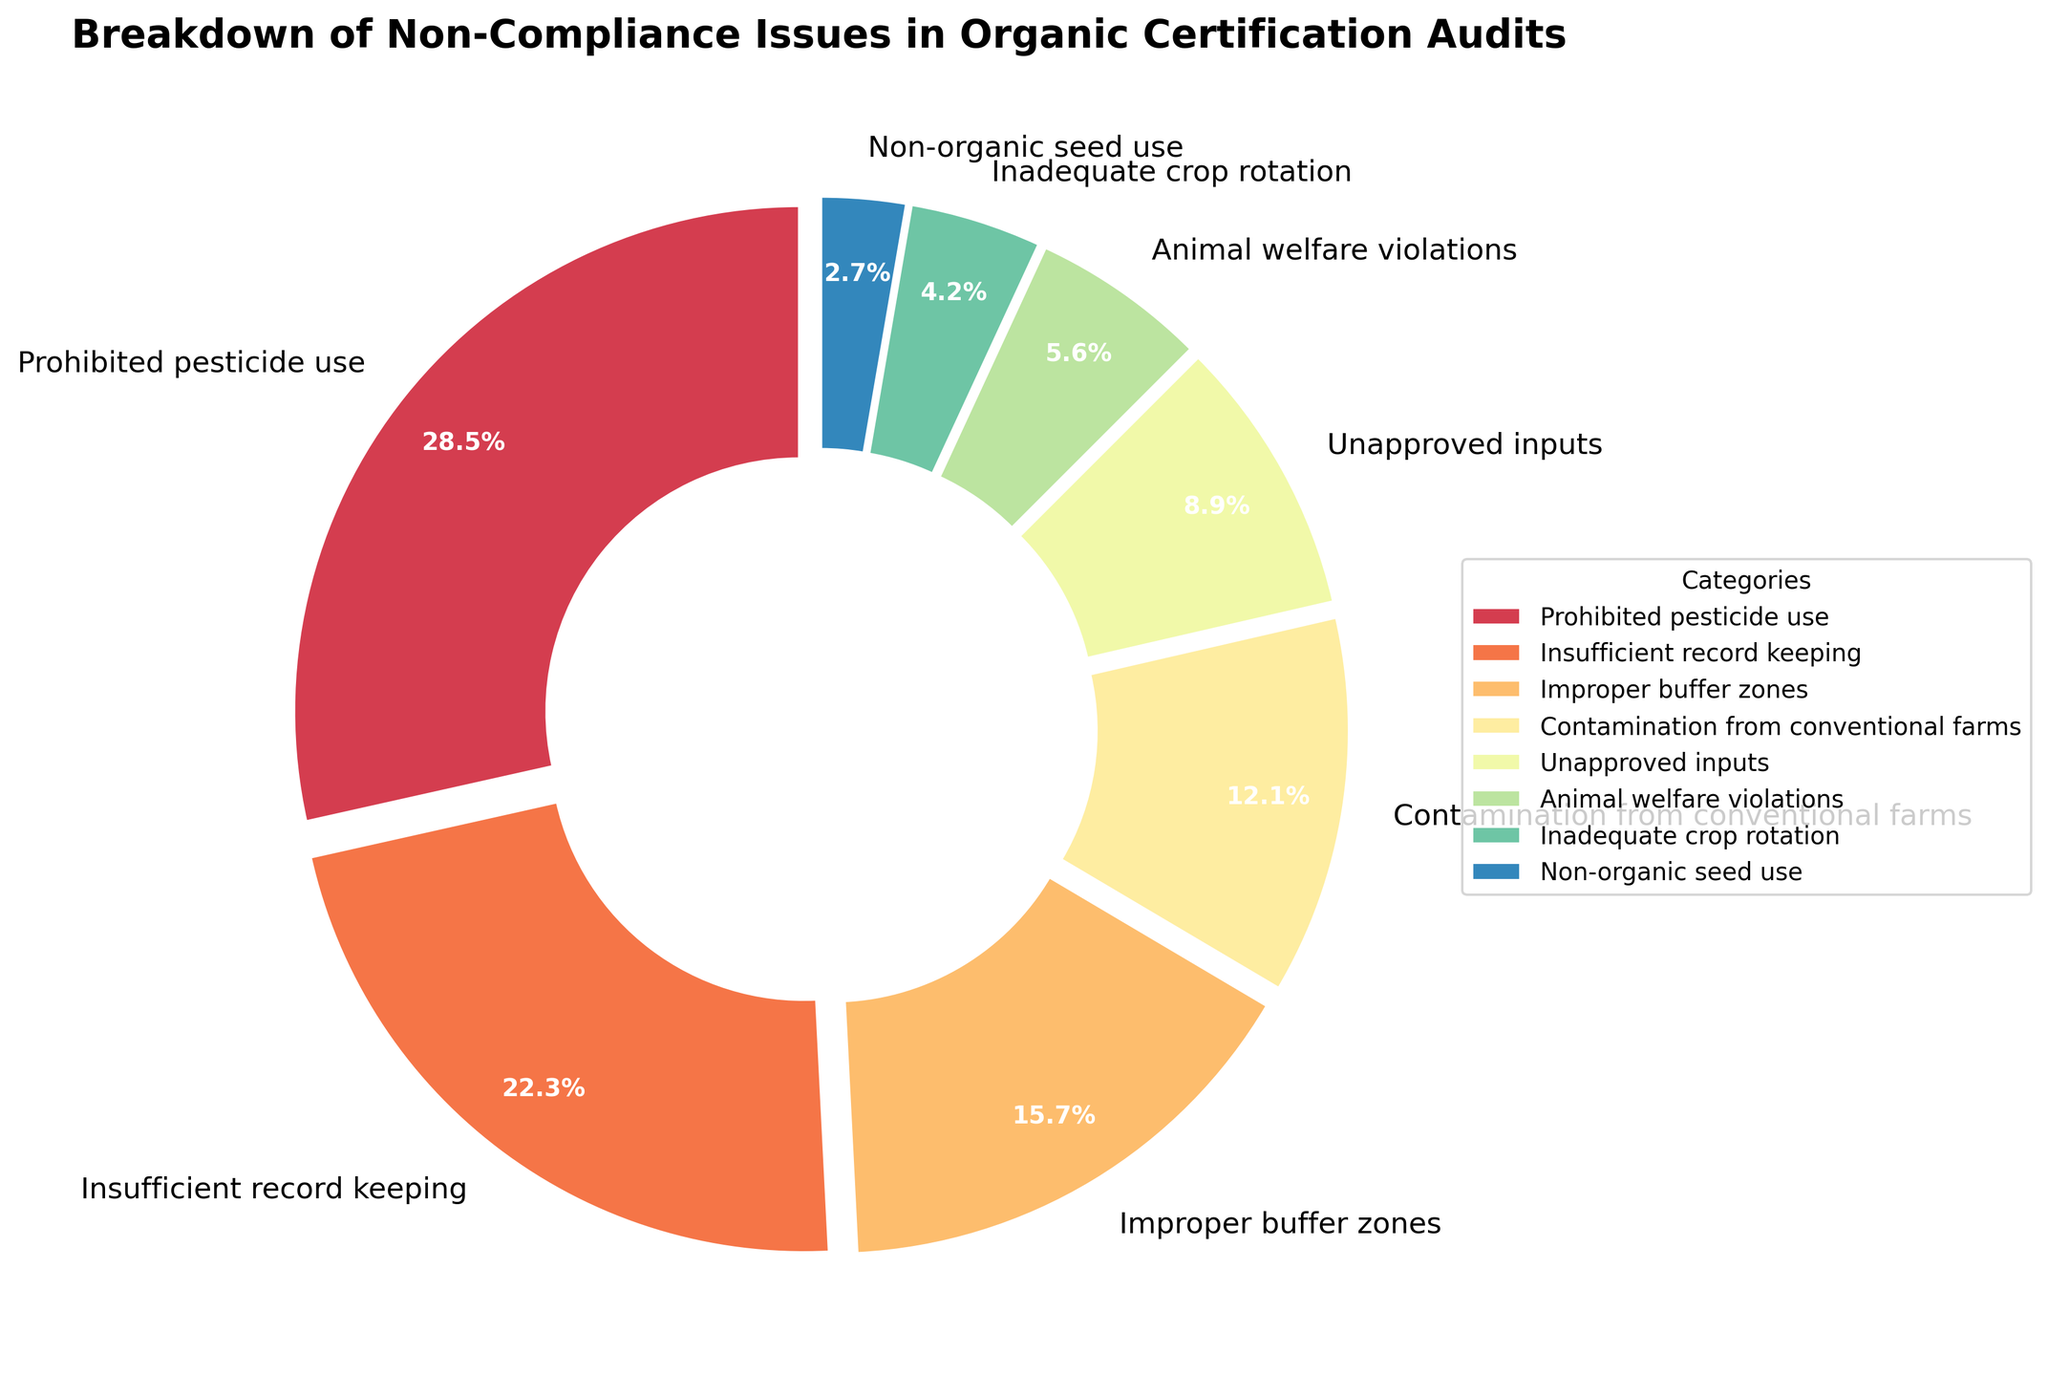What is the most common non-compliance issue? The category with the highest percentage in the pie chart represents the most common non-compliance issue. The "Prohibited pesticide use" slice is the largest with 28.5%.
Answer: Prohibited pesticide use Which non-compliance issue has a percentage closest to 15%? From the chart, locate the slice that has a value nearest to 15%. "Improper buffer zones" has a percentage of 15.7%.
Answer: Improper buffer zones Are there more issues related to "Prohibited pesticide use" or "Insufficient record keeping"? Compare the percentages of the "Prohibited pesticide use" and "Insufficient record keeping" categories. "Prohibited pesticide use" is 28.5%, and "Insufficient record keeping" is 22.3%. 28.5% is higher than 22.3%.
Answer: Prohibited pesticide use Which two categories combined have a total percentage of over 40%? Identify any two categories whose combined percentages add up to more than 40%. "Prohibited pesticide use" (28.5%) and "Insufficient record keeping" (22.3%) sum to 50.8%, which is over 40%.
Answer: Prohibited pesticide use and Insufficient record keeping What is the approximate total percentage of issues related to the top three categories? Add the percentages of the three largest slices: "Prohibited pesticide use" (28.5%), "Insufficient record keeping" (22.3%), and "Improper buffer zones" (15.7%). The sum is 28.5% + 22.3% + 15.7% = 66.5%.
Answer: 66.5% Which issue is least common, and what is its percentage? The smallest slice represents the least common issue. "Non-organic seed use" has the smallest percentage at 2.7%.
Answer: Non-organic seed use, 2.7% Is the percentage of issues related to "Contamination from conventional farms" greater than "Unapproved inputs"? Compare the percentage values of "Contamination from conventional farms" (12.1%) and "Unapproved inputs" (8.9%). 12.1% is greater than 8.9%.
Answer: Yes What is the total percentage of issues that involve some form of contamination? Sum up the percentages of all categories related to contamination: "Prohibited pesticide use" (28.5%) and "Contamination from conventional farms" (12.1%). The total is 28.5% + 12.1% = 40.6%.
Answer: 40.6% How does the percentage of "Animal welfare violations" compare to "Inadequate crop rotation"? Compare the percentages of "Animal welfare violations" (5.6%) and "Inadequate crop rotation" (4.2%). 5.6% is greater than 4.2%.
Answer: Greater What percentage of issues are related to animal welfare or non-organic seed use? Add the percentages of "Animal welfare violations" (5.6%) and "Non-organic seed use" (2.7%). The sum is 5.6% + 2.7% = 8.3%.
Answer: 8.3% 